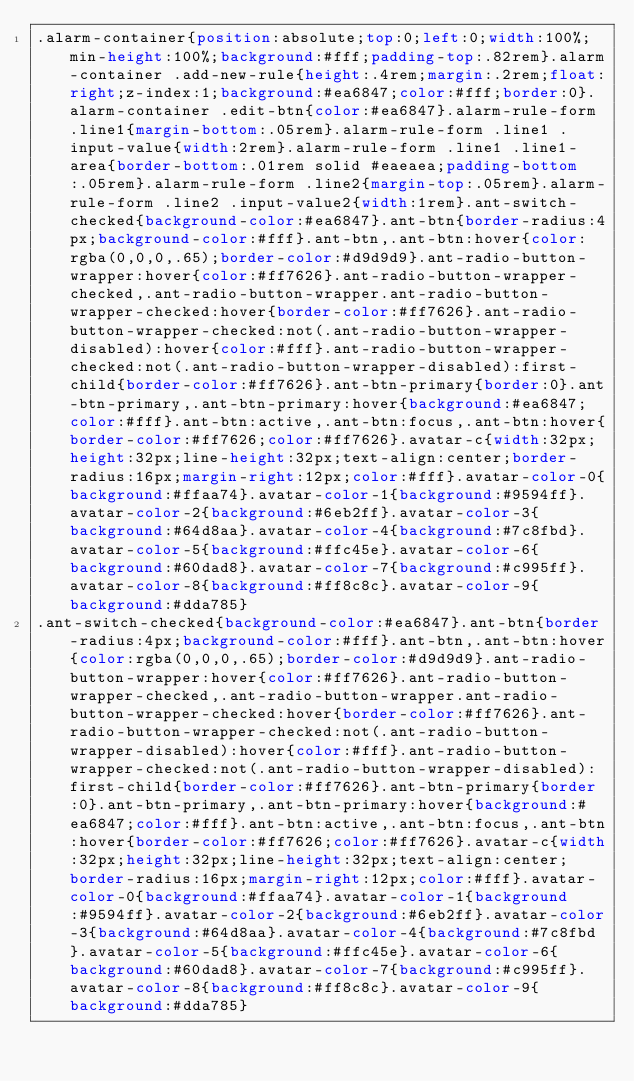<code> <loc_0><loc_0><loc_500><loc_500><_CSS_>.alarm-container{position:absolute;top:0;left:0;width:100%;min-height:100%;background:#fff;padding-top:.82rem}.alarm-container .add-new-rule{height:.4rem;margin:.2rem;float:right;z-index:1;background:#ea6847;color:#fff;border:0}.alarm-container .edit-btn{color:#ea6847}.alarm-rule-form .line1{margin-bottom:.05rem}.alarm-rule-form .line1 .input-value{width:2rem}.alarm-rule-form .line1 .line1-area{border-bottom:.01rem solid #eaeaea;padding-bottom:.05rem}.alarm-rule-form .line2{margin-top:.05rem}.alarm-rule-form .line2 .input-value2{width:1rem}.ant-switch-checked{background-color:#ea6847}.ant-btn{border-radius:4px;background-color:#fff}.ant-btn,.ant-btn:hover{color:rgba(0,0,0,.65);border-color:#d9d9d9}.ant-radio-button-wrapper:hover{color:#ff7626}.ant-radio-button-wrapper-checked,.ant-radio-button-wrapper.ant-radio-button-wrapper-checked:hover{border-color:#ff7626}.ant-radio-button-wrapper-checked:not(.ant-radio-button-wrapper-disabled):hover{color:#fff}.ant-radio-button-wrapper-checked:not(.ant-radio-button-wrapper-disabled):first-child{border-color:#ff7626}.ant-btn-primary{border:0}.ant-btn-primary,.ant-btn-primary:hover{background:#ea6847;color:#fff}.ant-btn:active,.ant-btn:focus,.ant-btn:hover{border-color:#ff7626;color:#ff7626}.avatar-c{width:32px;height:32px;line-height:32px;text-align:center;border-radius:16px;margin-right:12px;color:#fff}.avatar-color-0{background:#ffaa74}.avatar-color-1{background:#9594ff}.avatar-color-2{background:#6eb2ff}.avatar-color-3{background:#64d8aa}.avatar-color-4{background:#7c8fbd}.avatar-color-5{background:#ffc45e}.avatar-color-6{background:#60dad8}.avatar-color-7{background:#c995ff}.avatar-color-8{background:#ff8c8c}.avatar-color-9{background:#dda785}
.ant-switch-checked{background-color:#ea6847}.ant-btn{border-radius:4px;background-color:#fff}.ant-btn,.ant-btn:hover{color:rgba(0,0,0,.65);border-color:#d9d9d9}.ant-radio-button-wrapper:hover{color:#ff7626}.ant-radio-button-wrapper-checked,.ant-radio-button-wrapper.ant-radio-button-wrapper-checked:hover{border-color:#ff7626}.ant-radio-button-wrapper-checked:not(.ant-radio-button-wrapper-disabled):hover{color:#fff}.ant-radio-button-wrapper-checked:not(.ant-radio-button-wrapper-disabled):first-child{border-color:#ff7626}.ant-btn-primary{border:0}.ant-btn-primary,.ant-btn-primary:hover{background:#ea6847;color:#fff}.ant-btn:active,.ant-btn:focus,.ant-btn:hover{border-color:#ff7626;color:#ff7626}.avatar-c{width:32px;height:32px;line-height:32px;text-align:center;border-radius:16px;margin-right:12px;color:#fff}.avatar-color-0{background:#ffaa74}.avatar-color-1{background:#9594ff}.avatar-color-2{background:#6eb2ff}.avatar-color-3{background:#64d8aa}.avatar-color-4{background:#7c8fbd}.avatar-color-5{background:#ffc45e}.avatar-color-6{background:#60dad8}.avatar-color-7{background:#c995ff}.avatar-color-8{background:#ff8c8c}.avatar-color-9{background:#dda785}</code> 